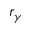Convert formula to latex. <formula><loc_0><loc_0><loc_500><loc_500>r _ { \gamma }</formula> 